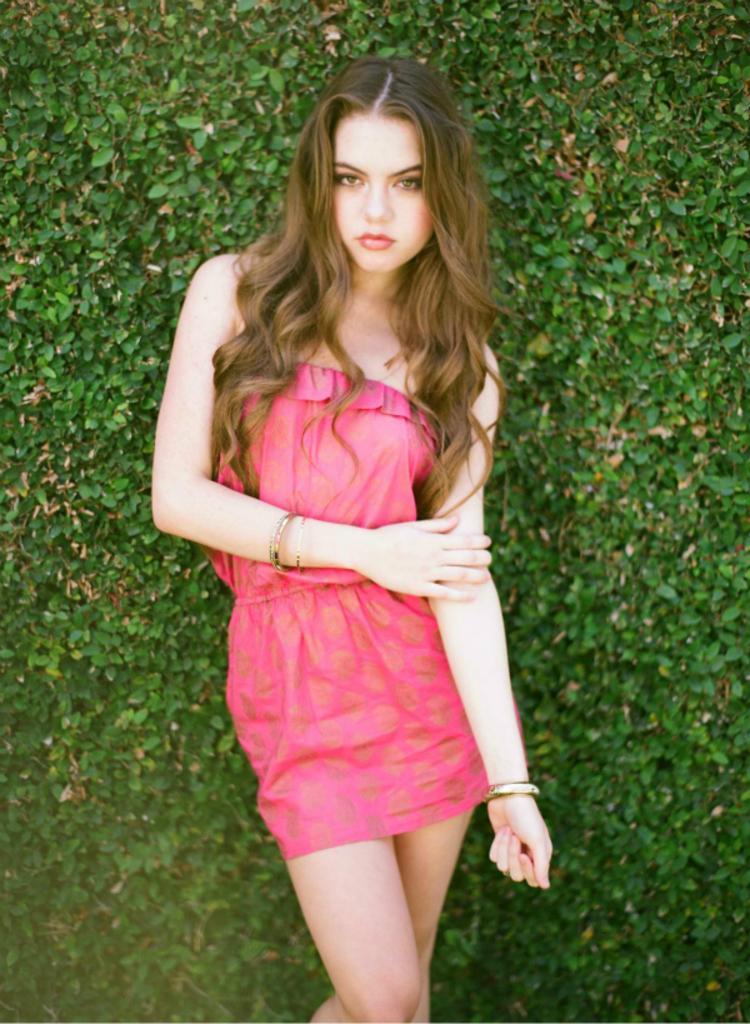How would you summarize this image in a sentence or two? In this image, I can see the woman standing. In the background, I can see the trees, which are green in color. 